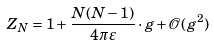Convert formula to latex. <formula><loc_0><loc_0><loc_500><loc_500>Z _ { N } = 1 + \frac { N ( N - 1 ) } { 4 \pi \varepsilon } \cdot g + \mathcal { O } ( g ^ { 2 } )</formula> 